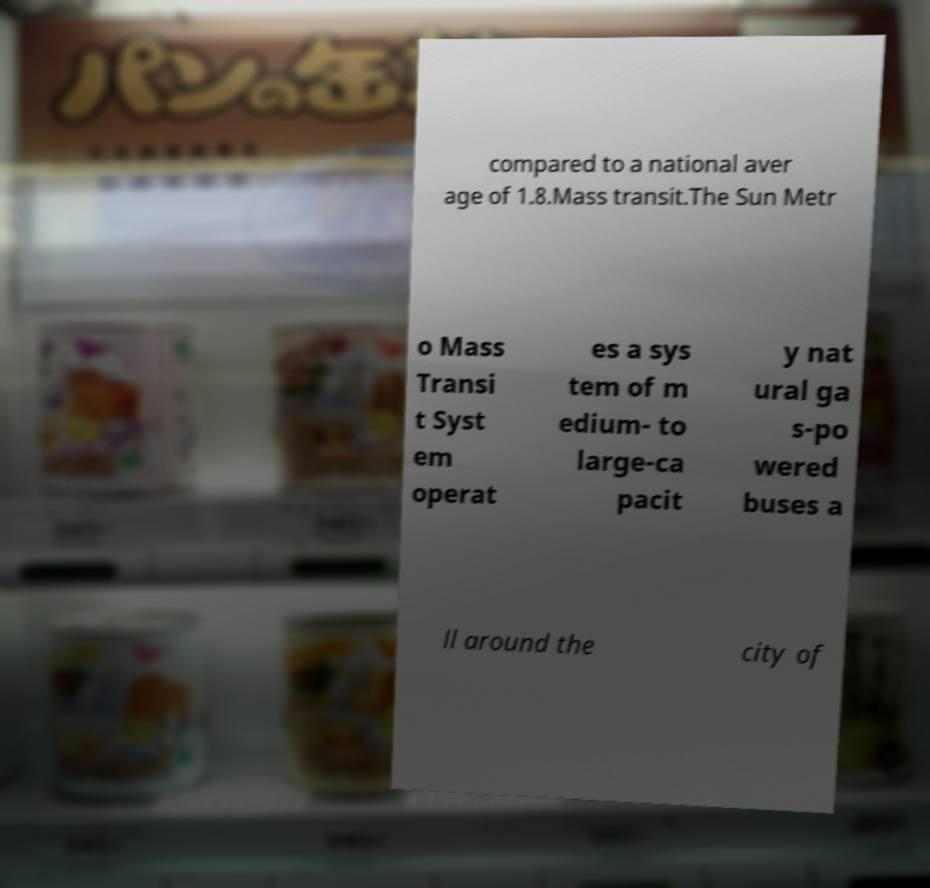Can you accurately transcribe the text from the provided image for me? compared to a national aver age of 1.8.Mass transit.The Sun Metr o Mass Transi t Syst em operat es a sys tem of m edium- to large-ca pacit y nat ural ga s-po wered buses a ll around the city of 